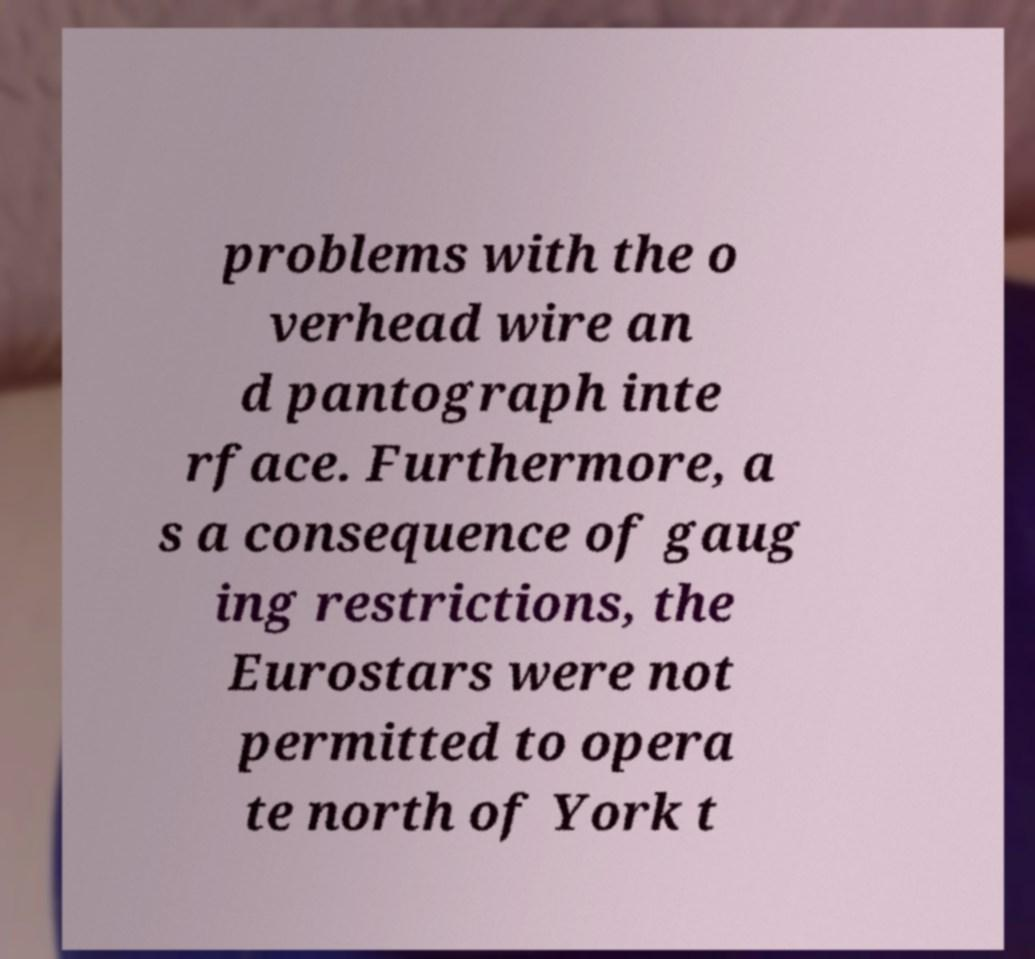Can you read and provide the text displayed in the image?This photo seems to have some interesting text. Can you extract and type it out for me? problems with the o verhead wire an d pantograph inte rface. Furthermore, a s a consequence of gaug ing restrictions, the Eurostars were not permitted to opera te north of York t 